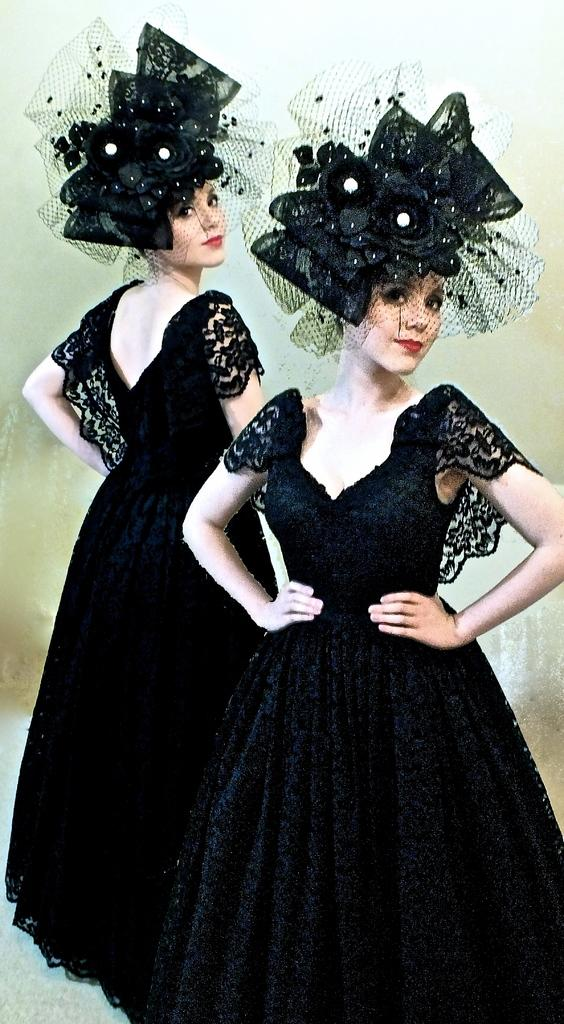How many women are in the image? There are two women in the image. What are the women doing in the image? The women are standing. What are the women wearing in the image? The women are wearing black dresses and hats. Can you describe the floor visible at the bottom of the image? The floor is visible at the bottom of the image, but no specific details about its appearance are provided. Is there any object visible in the background of the image? There might be a glass in the background of the image. What type of carriage can be seen in the background of the image? There is no carriage present in the image. What is the afterthought of the women in the image? The provided facts do not mention any afterthoughts of the women, and therefore this cannot be answered. 